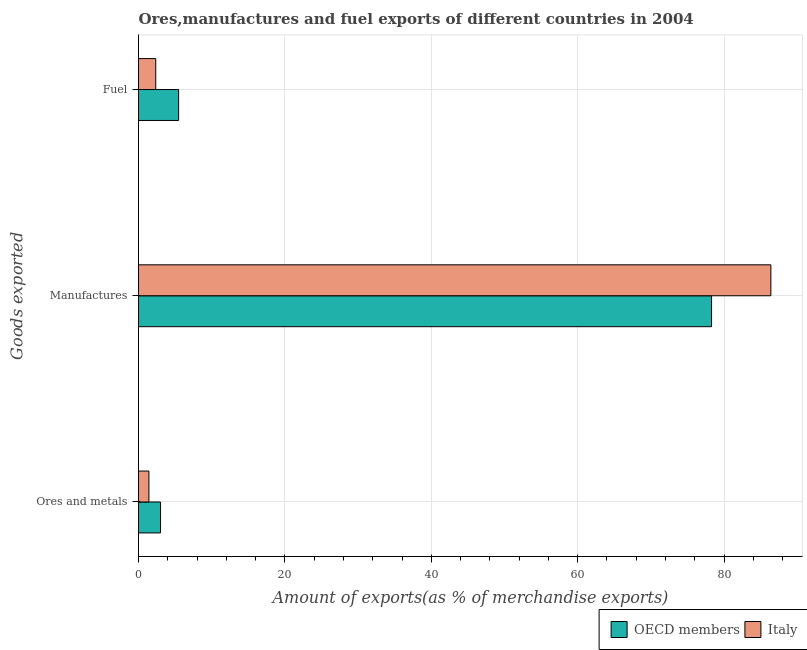How many groups of bars are there?
Offer a terse response. 3. Are the number of bars on each tick of the Y-axis equal?
Your answer should be very brief. Yes. What is the label of the 2nd group of bars from the top?
Your answer should be very brief. Manufactures. What is the percentage of fuel exports in OECD members?
Provide a succinct answer. 5.48. Across all countries, what is the maximum percentage of manufactures exports?
Keep it short and to the point. 86.39. Across all countries, what is the minimum percentage of manufactures exports?
Keep it short and to the point. 78.29. In which country was the percentage of manufactures exports minimum?
Your answer should be compact. OECD members. What is the total percentage of ores and metals exports in the graph?
Your response must be concise. 4.43. What is the difference between the percentage of fuel exports in Italy and that in OECD members?
Ensure brevity in your answer.  -3.12. What is the difference between the percentage of manufactures exports in Italy and the percentage of fuel exports in OECD members?
Your response must be concise. 80.91. What is the average percentage of manufactures exports per country?
Your answer should be very brief. 82.34. What is the difference between the percentage of ores and metals exports and percentage of fuel exports in Italy?
Your response must be concise. -0.94. What is the ratio of the percentage of ores and metals exports in Italy to that in OECD members?
Ensure brevity in your answer.  0.47. What is the difference between the highest and the second highest percentage of manufactures exports?
Keep it short and to the point. 8.1. What is the difference between the highest and the lowest percentage of fuel exports?
Provide a short and direct response. 3.12. Is the sum of the percentage of fuel exports in OECD members and Italy greater than the maximum percentage of ores and metals exports across all countries?
Ensure brevity in your answer.  Yes. What does the 2nd bar from the bottom in Fuel represents?
Offer a terse response. Italy. How many bars are there?
Give a very brief answer. 6. Are all the bars in the graph horizontal?
Provide a succinct answer. Yes. What is the difference between two consecutive major ticks on the X-axis?
Provide a short and direct response. 20. Where does the legend appear in the graph?
Provide a succinct answer. Bottom right. How many legend labels are there?
Make the answer very short. 2. How are the legend labels stacked?
Your response must be concise. Horizontal. What is the title of the graph?
Give a very brief answer. Ores,manufactures and fuel exports of different countries in 2004. What is the label or title of the X-axis?
Your answer should be very brief. Amount of exports(as % of merchandise exports). What is the label or title of the Y-axis?
Ensure brevity in your answer.  Goods exported. What is the Amount of exports(as % of merchandise exports) of OECD members in Ores and metals?
Your response must be concise. 3.01. What is the Amount of exports(as % of merchandise exports) in Italy in Ores and metals?
Offer a terse response. 1.42. What is the Amount of exports(as % of merchandise exports) of OECD members in Manufactures?
Give a very brief answer. 78.29. What is the Amount of exports(as % of merchandise exports) of Italy in Manufactures?
Provide a short and direct response. 86.39. What is the Amount of exports(as % of merchandise exports) in OECD members in Fuel?
Your answer should be compact. 5.48. What is the Amount of exports(as % of merchandise exports) in Italy in Fuel?
Offer a very short reply. 2.36. Across all Goods exported, what is the maximum Amount of exports(as % of merchandise exports) of OECD members?
Offer a very short reply. 78.29. Across all Goods exported, what is the maximum Amount of exports(as % of merchandise exports) of Italy?
Provide a short and direct response. 86.39. Across all Goods exported, what is the minimum Amount of exports(as % of merchandise exports) in OECD members?
Provide a short and direct response. 3.01. Across all Goods exported, what is the minimum Amount of exports(as % of merchandise exports) in Italy?
Provide a succinct answer. 1.42. What is the total Amount of exports(as % of merchandise exports) in OECD members in the graph?
Your answer should be compact. 86.78. What is the total Amount of exports(as % of merchandise exports) in Italy in the graph?
Your response must be concise. 90.17. What is the difference between the Amount of exports(as % of merchandise exports) in OECD members in Ores and metals and that in Manufactures?
Provide a short and direct response. -75.28. What is the difference between the Amount of exports(as % of merchandise exports) of Italy in Ores and metals and that in Manufactures?
Your answer should be very brief. -84.97. What is the difference between the Amount of exports(as % of merchandise exports) of OECD members in Ores and metals and that in Fuel?
Offer a terse response. -2.47. What is the difference between the Amount of exports(as % of merchandise exports) of Italy in Ores and metals and that in Fuel?
Your answer should be very brief. -0.94. What is the difference between the Amount of exports(as % of merchandise exports) in OECD members in Manufactures and that in Fuel?
Your answer should be very brief. 72.81. What is the difference between the Amount of exports(as % of merchandise exports) of Italy in Manufactures and that in Fuel?
Offer a terse response. 84.04. What is the difference between the Amount of exports(as % of merchandise exports) of OECD members in Ores and metals and the Amount of exports(as % of merchandise exports) of Italy in Manufactures?
Your response must be concise. -83.38. What is the difference between the Amount of exports(as % of merchandise exports) in OECD members in Ores and metals and the Amount of exports(as % of merchandise exports) in Italy in Fuel?
Make the answer very short. 0.65. What is the difference between the Amount of exports(as % of merchandise exports) of OECD members in Manufactures and the Amount of exports(as % of merchandise exports) of Italy in Fuel?
Your response must be concise. 75.93. What is the average Amount of exports(as % of merchandise exports) of OECD members per Goods exported?
Give a very brief answer. 28.93. What is the average Amount of exports(as % of merchandise exports) in Italy per Goods exported?
Ensure brevity in your answer.  30.06. What is the difference between the Amount of exports(as % of merchandise exports) in OECD members and Amount of exports(as % of merchandise exports) in Italy in Ores and metals?
Your answer should be compact. 1.59. What is the difference between the Amount of exports(as % of merchandise exports) in OECD members and Amount of exports(as % of merchandise exports) in Italy in Manufactures?
Your answer should be very brief. -8.1. What is the difference between the Amount of exports(as % of merchandise exports) of OECD members and Amount of exports(as % of merchandise exports) of Italy in Fuel?
Your answer should be compact. 3.12. What is the ratio of the Amount of exports(as % of merchandise exports) in OECD members in Ores and metals to that in Manufactures?
Ensure brevity in your answer.  0.04. What is the ratio of the Amount of exports(as % of merchandise exports) in Italy in Ores and metals to that in Manufactures?
Your response must be concise. 0.02. What is the ratio of the Amount of exports(as % of merchandise exports) of OECD members in Ores and metals to that in Fuel?
Your answer should be compact. 0.55. What is the ratio of the Amount of exports(as % of merchandise exports) in Italy in Ores and metals to that in Fuel?
Provide a short and direct response. 0.6. What is the ratio of the Amount of exports(as % of merchandise exports) in OECD members in Manufactures to that in Fuel?
Ensure brevity in your answer.  14.29. What is the ratio of the Amount of exports(as % of merchandise exports) in Italy in Manufactures to that in Fuel?
Give a very brief answer. 36.67. What is the difference between the highest and the second highest Amount of exports(as % of merchandise exports) of OECD members?
Your answer should be compact. 72.81. What is the difference between the highest and the second highest Amount of exports(as % of merchandise exports) of Italy?
Your answer should be compact. 84.04. What is the difference between the highest and the lowest Amount of exports(as % of merchandise exports) in OECD members?
Offer a very short reply. 75.28. What is the difference between the highest and the lowest Amount of exports(as % of merchandise exports) of Italy?
Offer a very short reply. 84.97. 